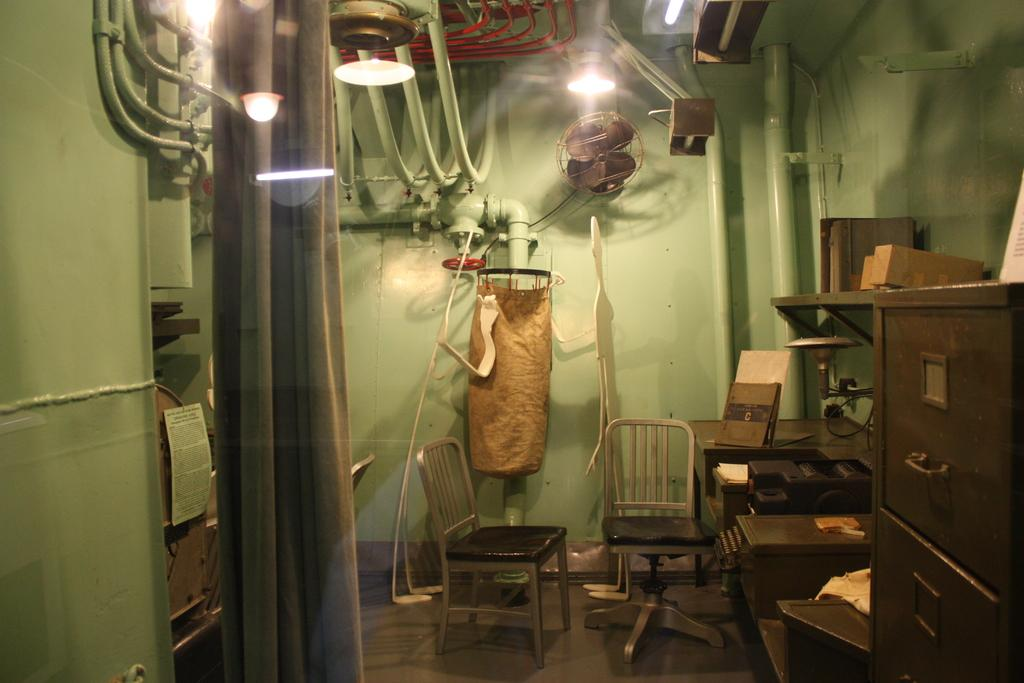What type of furniture is present in the image? There are chairs in the image. What appliance can be seen in the image? There is a fan in the image. What source of illumination is visible in the image? There is a light in the image. What type of storage container is present in the image? There is an iron box in the image. Can you see a hand making a request in the image? There is no hand making a request in the image. What type of floor is visible in the image? The provided facts do not mention the floor, so we cannot definitively answer this question. 